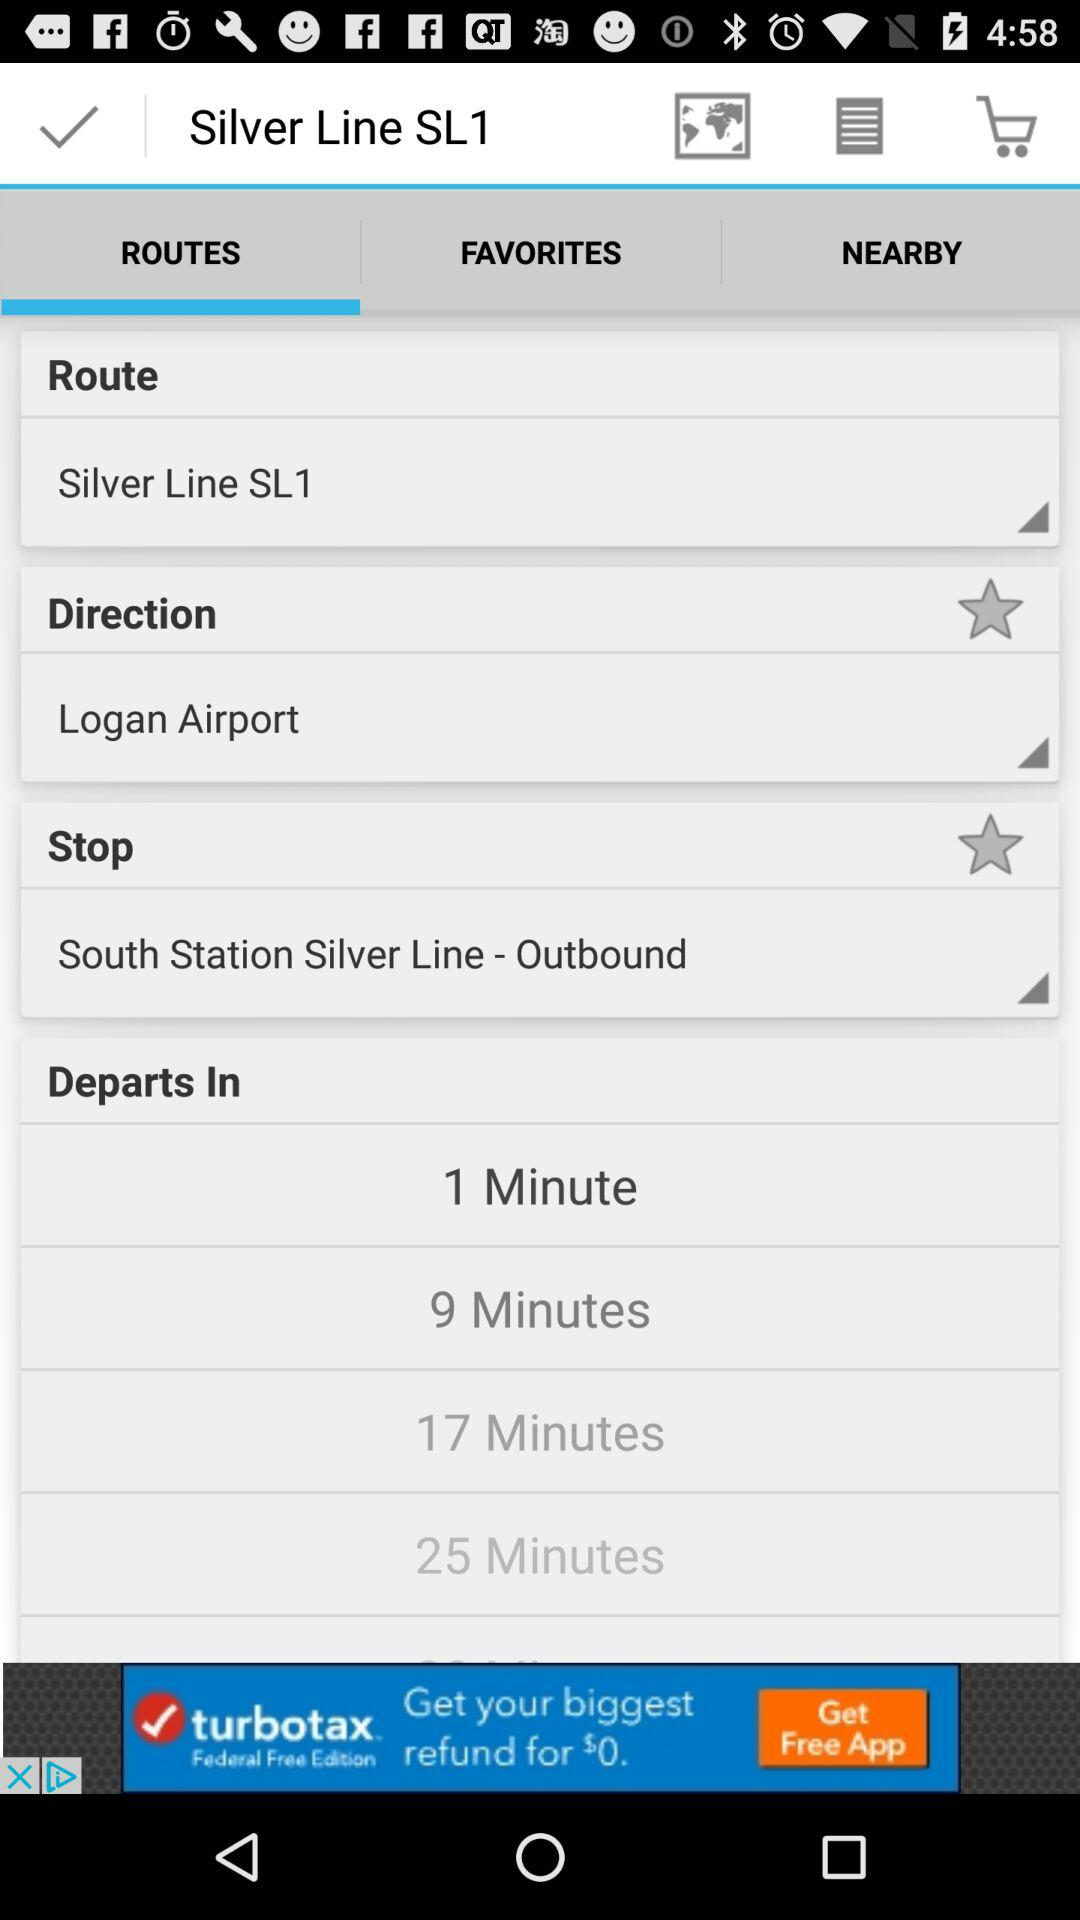What is the selected time duration? The selected time duration is 1 minute. 